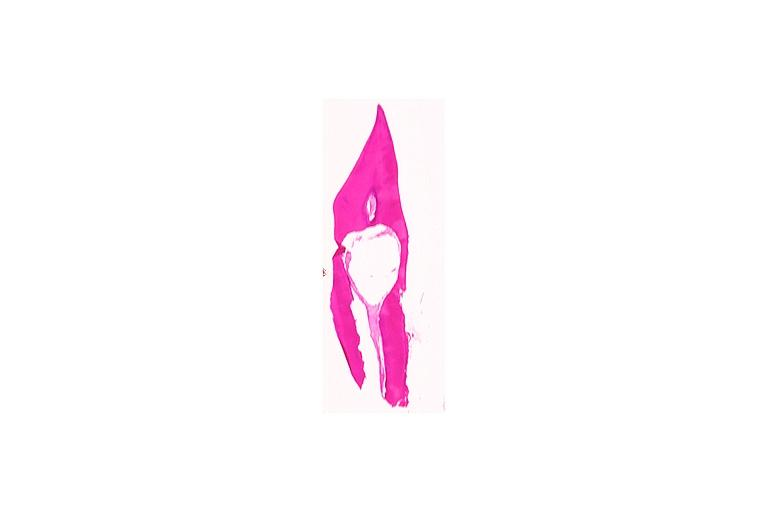does leiomyoma show internal resorption?
Answer the question using a single word or phrase. No 